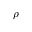Convert formula to latex. <formula><loc_0><loc_0><loc_500><loc_500>\rho</formula> 